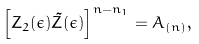Convert formula to latex. <formula><loc_0><loc_0><loc_500><loc_500>\left [ Z _ { 2 } ( \epsilon ) \tilde { Z } ( \epsilon ) \right ] ^ { n - n _ { 1 } } = A _ { ( n ) } ,</formula> 